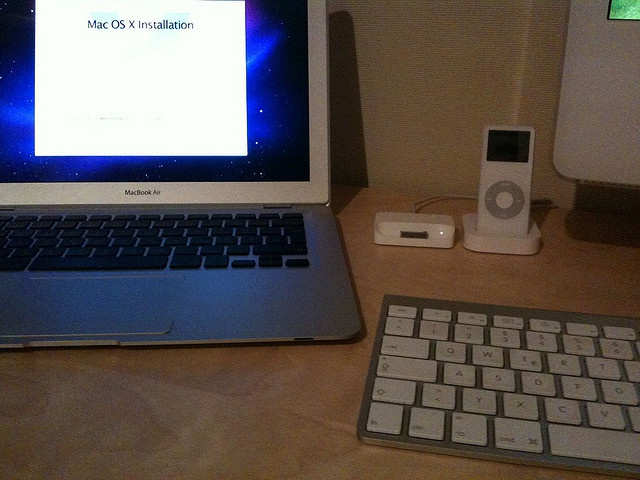Describe the objects in this image and their specific colors. I can see laptop in black, ivory, navy, and darkblue tones, keyboard in black, navy, darkblue, and gray tones, and keyboard in black, gray, and maroon tones in this image. 